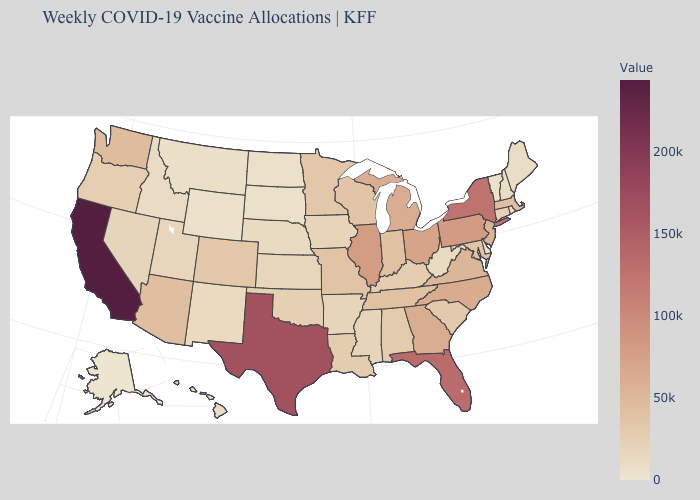Among the states that border Indiana , which have the highest value?
Concise answer only. Illinois. Does Texas have a lower value than California?
Concise answer only. Yes. Does Washington have the lowest value in the West?
Concise answer only. No. Among the states that border Massachusetts , which have the lowest value?
Give a very brief answer. Vermont. Which states have the lowest value in the USA?
Concise answer only. Alaska. Does California have the highest value in the USA?
Give a very brief answer. Yes. 